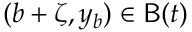Convert formula to latex. <formula><loc_0><loc_0><loc_500><loc_500>( b + \zeta , y _ { b } ) \in B ( t )</formula> 